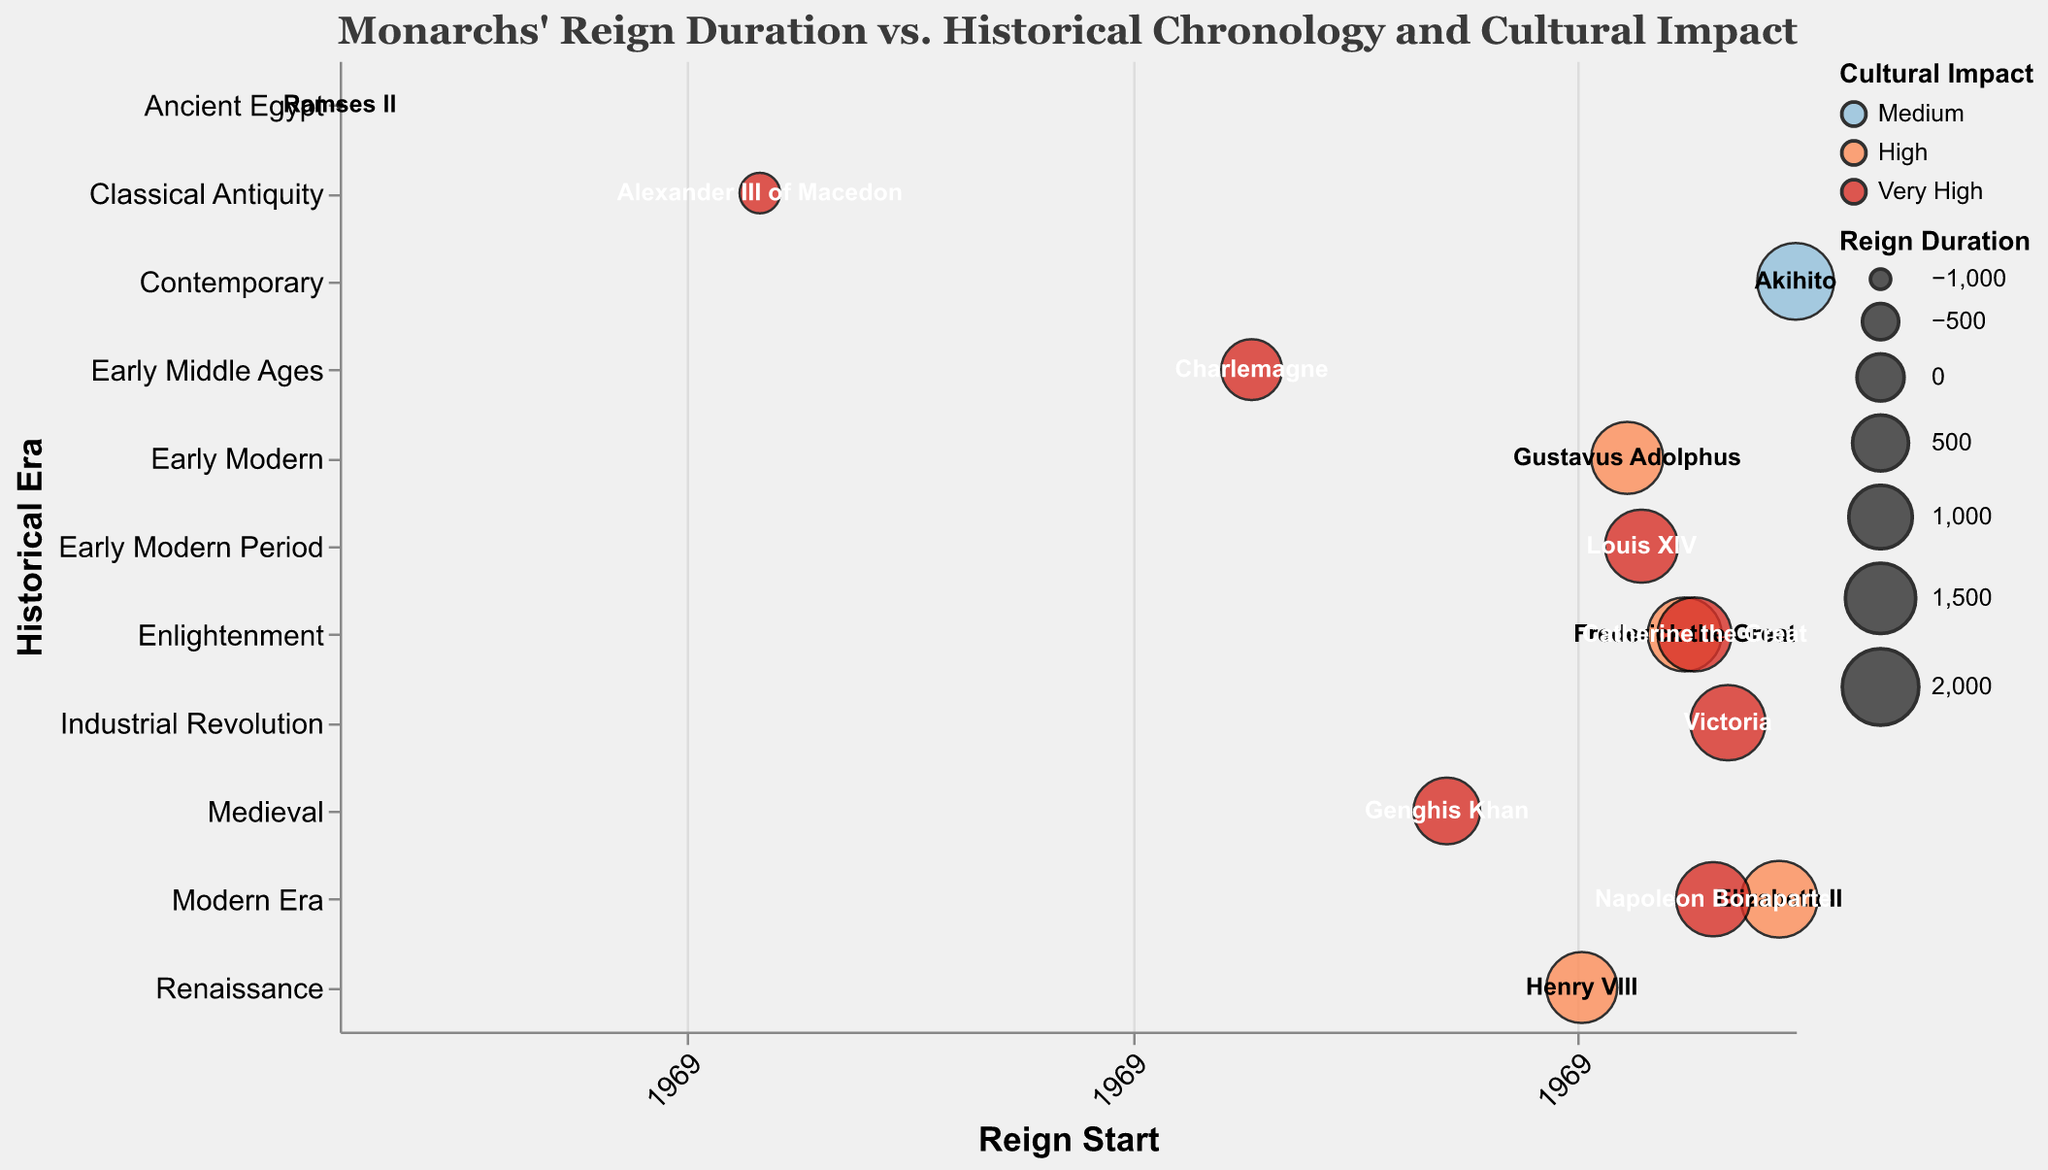What is the title of the chart? The chart title is located at the top center and is clearly written out. The title provides a summary of the chart's subject matter.
Answer: Monarchs' Reign Duration vs. Historical Chronology and Cultural Impact What are the axes labels? The x-axis label is marked as "Reign Start," denoting the beginning of each monarch's reign. The y-axis label is "Historical Era," indicating the historical period in which each monarch reigned.
Answer: Reign Start, Historical Era Which monarch had the longest reign, and how long was it? Look for the largest bubble in terms of circle size. Elizabeth II's reign started in 1952 and ended in 2022, resulting in a 70-year duration.
Answer: Elizabeth II, 70 years What color represents monarchs with "Very High" cultural impact? Observing the legend in the chart, the "Very High" cultural impact is colored in dark red.
Answer: Dark red Which monarch from the Early Modern Period has a very high cultural impact? Identify the bubbles within the "Early Modern Period" on the y-axis, and among them, find the one with the dark red color signifying "Very High" cultural impact.
Answer: Louis XIV How many monarchs are represented in the chart? Count the number of distinct data points (bubbles) in the chart. Each bubble represents one monarch.
Answer: 13 Which historical era has the most monarchs with "Very High" cultural impact? Look at the y-axis to find each historical era, then count the monarchs with dark red coloring within each era. Early Middle Ages and Enlightenment both have two such monarchs each.
Answer: Early Middle Ages, Enlightenment Which monarch had the shortest reign, and what was its duration? Try to find the smallest bubble in terms of size. Alexander III of Macedon’s reign lasted from 336 BC to 323 BC, resulting in a 13-year reign.
Answer: Alexander III of Macedon, 13 years Who had a longer reign, Genghis Khan or Gustavus Adolphus? Compare the reign duration by subtracting the start year from the end year for each monarch. Genghis Khan's reign lasted 21 years (1227 - 1206), and Gustavus Adolphus's reign lasted 21 years (1632 - 1611). Both reigns were equal in duration.
Answer: Both equal, 21 years Which monarchs belong to the "Enlightenment" era, and what are their cultural impacts? Find the bubbles placed on the "Enlightenment" row on the y-axis and check their associated colors representing cultural impacts. Frederick the Great has a "High" impact, and Catherine the Great has a "Very High" impact.
Answer: Frederick the Great: High, Catherine the Great: Very High 